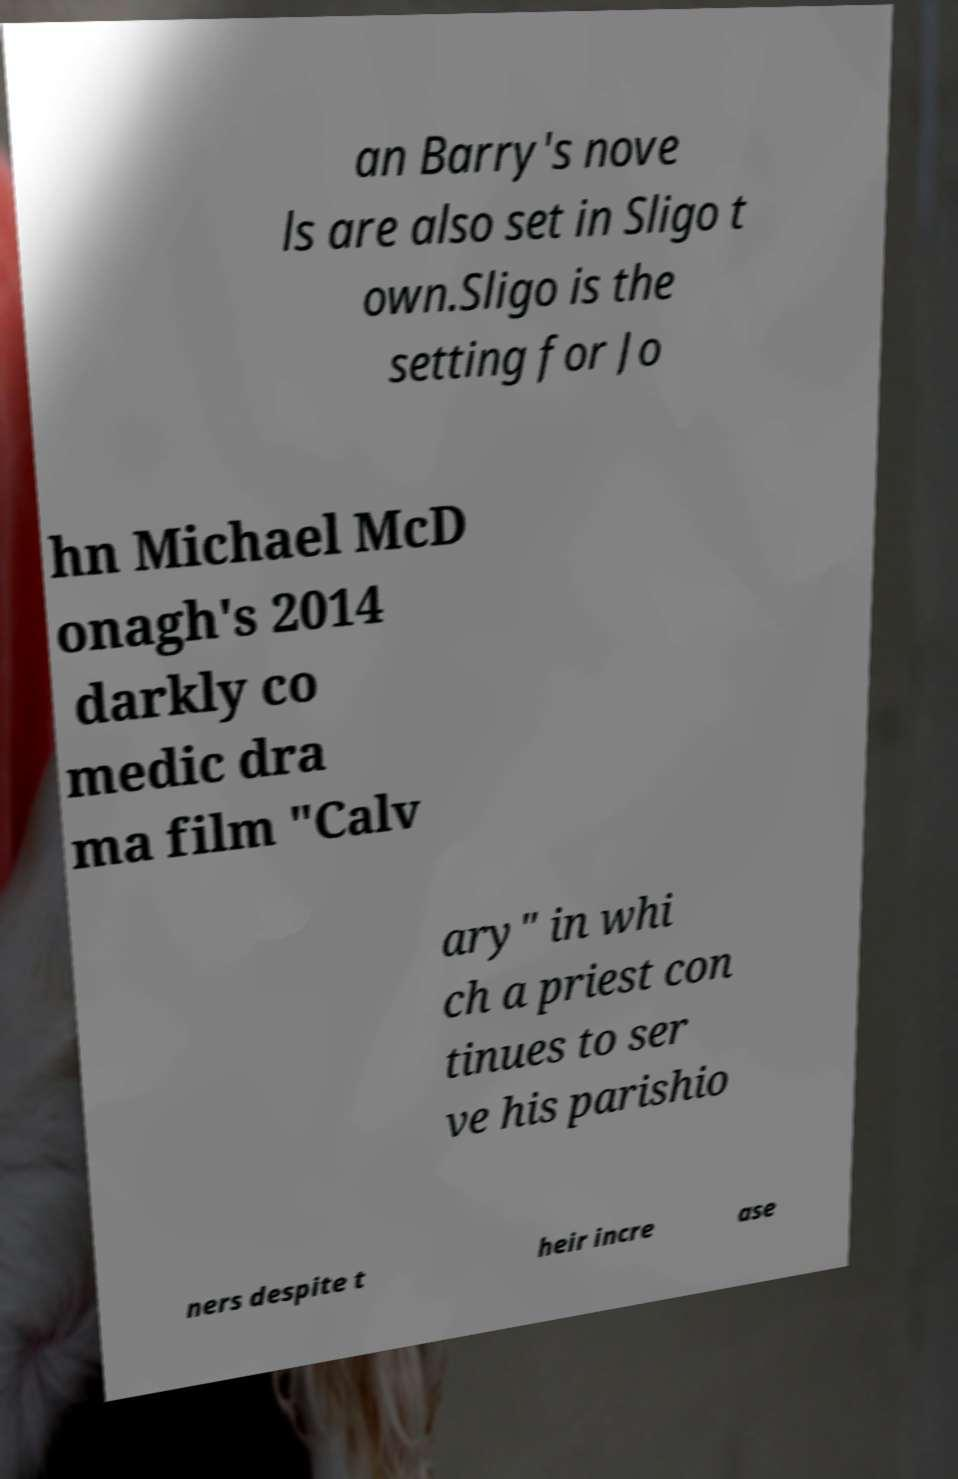Can you accurately transcribe the text from the provided image for me? an Barry's nove ls are also set in Sligo t own.Sligo is the setting for Jo hn Michael McD onagh's 2014 darkly co medic dra ma film "Calv ary" in whi ch a priest con tinues to ser ve his parishio ners despite t heir incre ase 